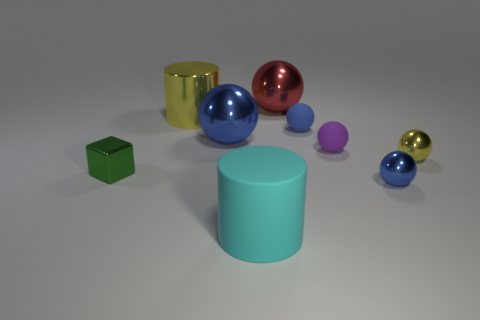How many blue spheres must be subtracted to get 1 blue spheres? 2 Subtract all green cylinders. How many blue spheres are left? 3 Subtract all purple balls. How many balls are left? 5 Subtract all small metal spheres. How many spheres are left? 4 Subtract all yellow spheres. Subtract all purple blocks. How many spheres are left? 5 Subtract all cubes. How many objects are left? 8 Add 3 metal cylinders. How many metal cylinders are left? 4 Add 3 green objects. How many green objects exist? 4 Subtract 1 blue balls. How many objects are left? 8 Subtract all small spheres. Subtract all small blue metal objects. How many objects are left? 4 